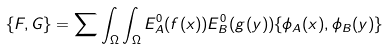<formula> <loc_0><loc_0><loc_500><loc_500>\{ F , G \} = \sum \int _ { \Omega } \int _ { \Omega } E ^ { 0 } _ { A } ( f ( x ) ) E ^ { 0 } _ { B } ( g ( y ) ) \{ \phi _ { A } ( x ) , \phi _ { B } ( y ) \}</formula> 